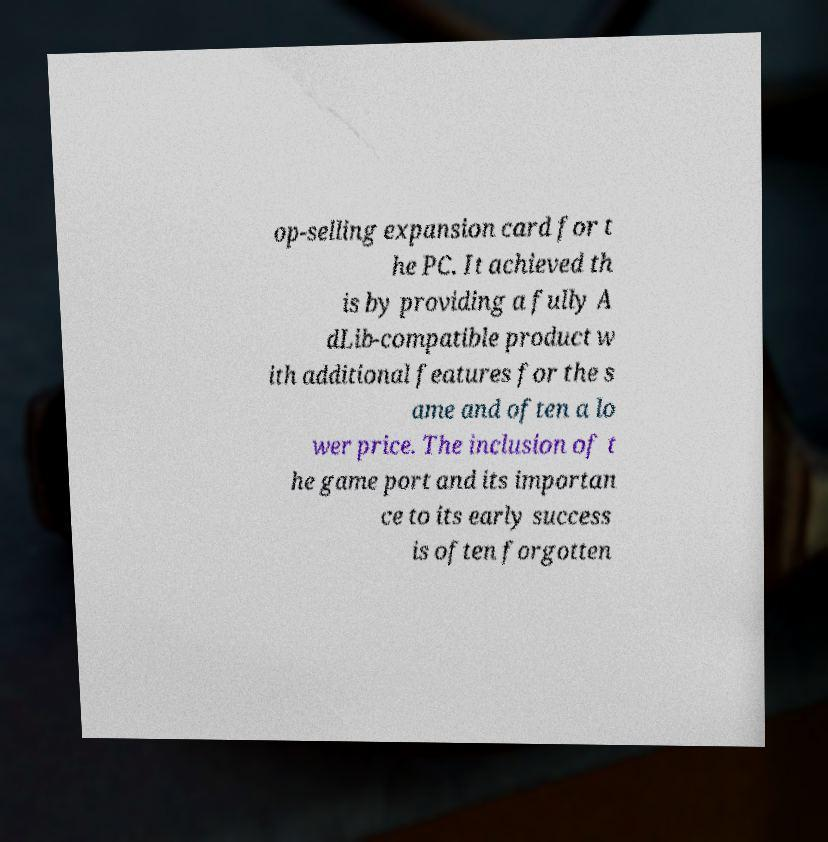Please identify and transcribe the text found in this image. op-selling expansion card for t he PC. It achieved th is by providing a fully A dLib-compatible product w ith additional features for the s ame and often a lo wer price. The inclusion of t he game port and its importan ce to its early success is often forgotten 